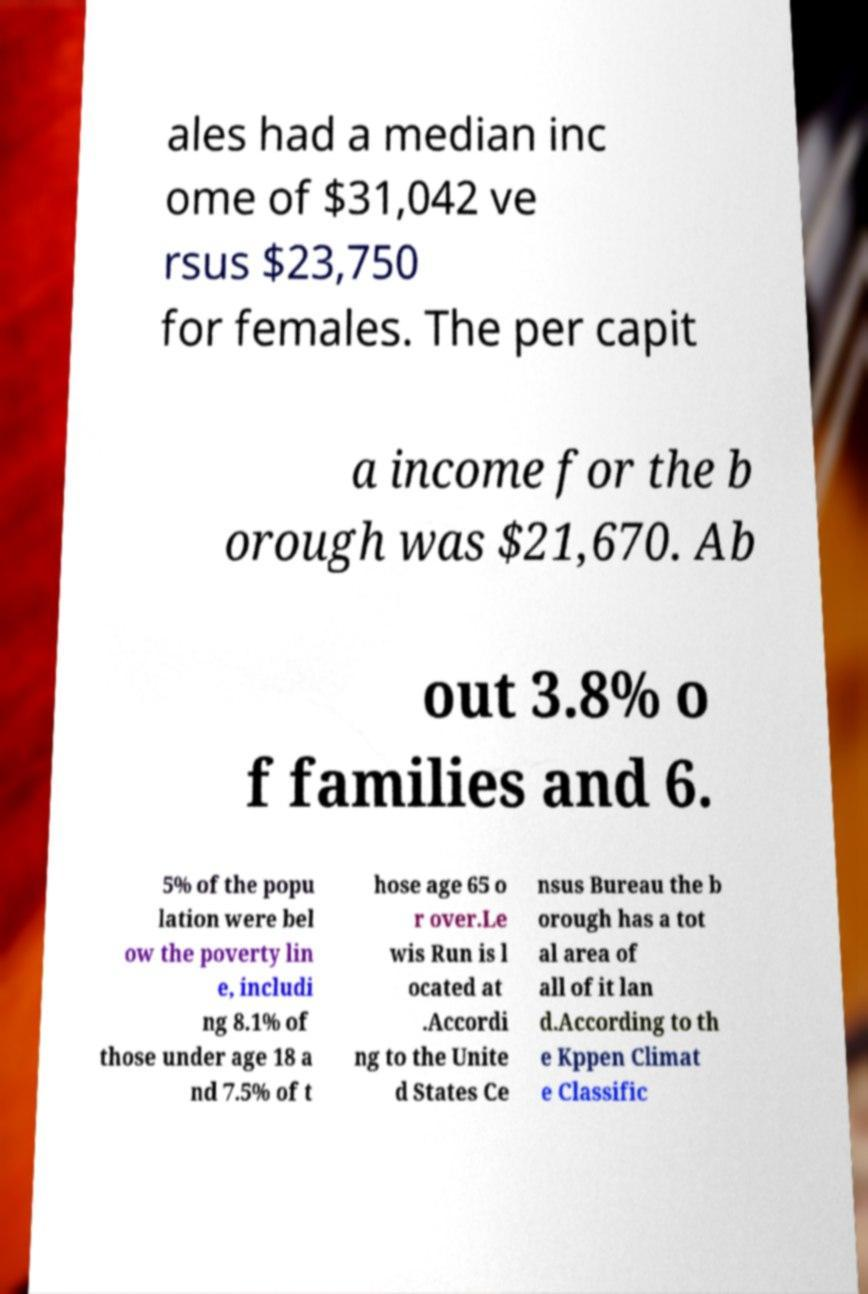Could you extract and type out the text from this image? ales had a median inc ome of $31,042 ve rsus $23,750 for females. The per capit a income for the b orough was $21,670. Ab out 3.8% o f families and 6. 5% of the popu lation were bel ow the poverty lin e, includi ng 8.1% of those under age 18 a nd 7.5% of t hose age 65 o r over.Le wis Run is l ocated at .Accordi ng to the Unite d States Ce nsus Bureau the b orough has a tot al area of all of it lan d.According to th e Kppen Climat e Classific 